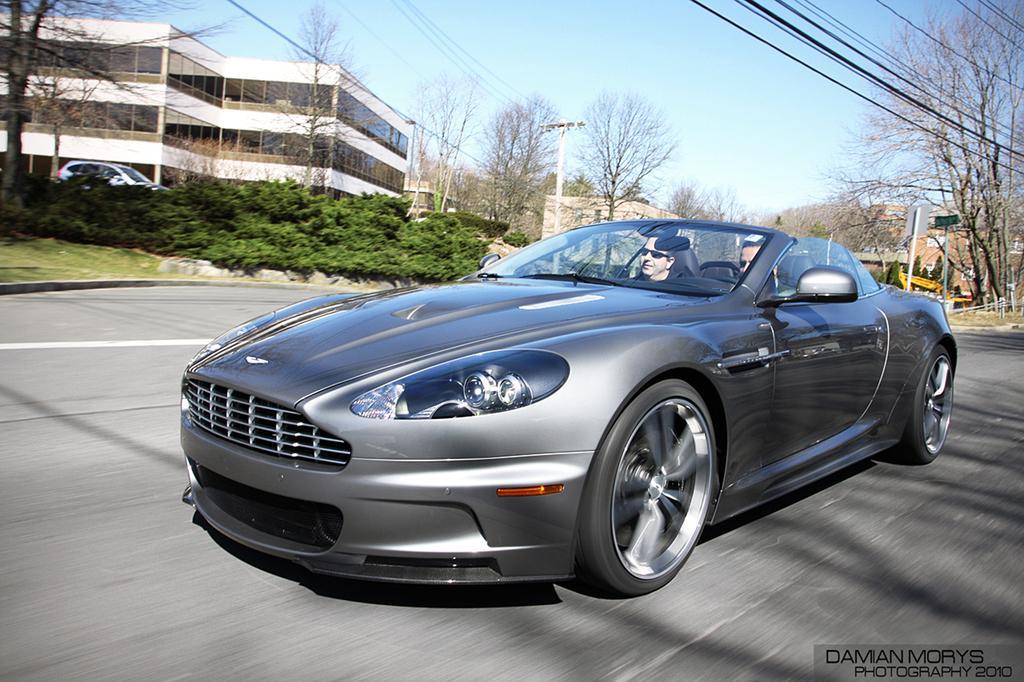Please provide a concise description of this image. In this image we can see men sitting in the motor vehicle on the road. In the background there are buildings, trees, shrubs, bushes, electric poles, electric cables, ground, motor vehicles, information boards, sign boards and sky. 